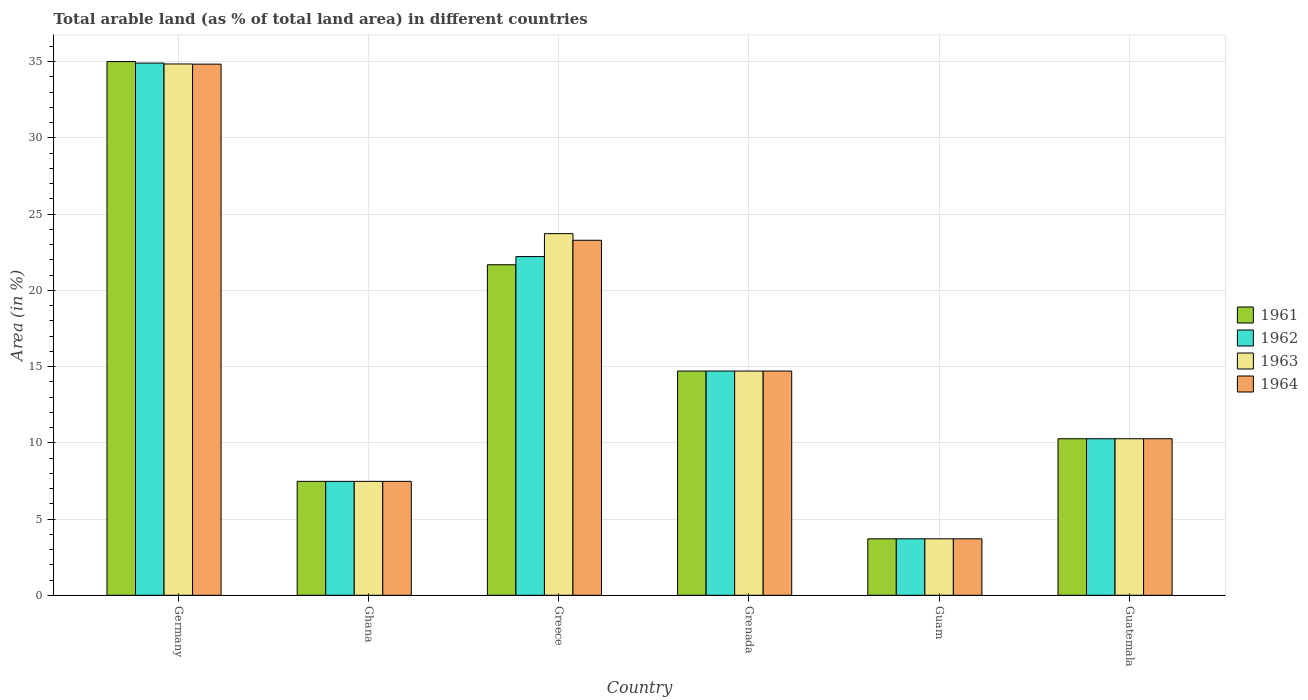How many groups of bars are there?
Make the answer very short. 6. Are the number of bars per tick equal to the number of legend labels?
Make the answer very short. Yes. Are the number of bars on each tick of the X-axis equal?
Give a very brief answer. Yes. How many bars are there on the 4th tick from the right?
Provide a short and direct response. 4. What is the label of the 1st group of bars from the left?
Ensure brevity in your answer.  Germany. What is the percentage of arable land in 1964 in Guam?
Offer a terse response. 3.7. Across all countries, what is the maximum percentage of arable land in 1964?
Your answer should be compact. 34.83. Across all countries, what is the minimum percentage of arable land in 1963?
Your response must be concise. 3.7. In which country was the percentage of arable land in 1963 maximum?
Offer a very short reply. Germany. In which country was the percentage of arable land in 1964 minimum?
Ensure brevity in your answer.  Guam. What is the total percentage of arable land in 1963 in the graph?
Offer a very short reply. 94.71. What is the difference between the percentage of arable land in 1961 in Greece and that in Grenada?
Offer a very short reply. 6.97. What is the difference between the percentage of arable land in 1961 in Germany and the percentage of arable land in 1962 in Guatemala?
Provide a short and direct response. 24.74. What is the average percentage of arable land in 1962 per country?
Ensure brevity in your answer.  15.54. What is the difference between the percentage of arable land of/in 1963 and percentage of arable land of/in 1961 in Germany?
Provide a succinct answer. -0.16. In how many countries, is the percentage of arable land in 1964 greater than 6 %?
Offer a terse response. 5. What is the ratio of the percentage of arable land in 1962 in Germany to that in Grenada?
Ensure brevity in your answer.  2.37. Is the percentage of arable land in 1961 in Greece less than that in Guam?
Ensure brevity in your answer.  No. What is the difference between the highest and the second highest percentage of arable land in 1963?
Make the answer very short. 20.14. What is the difference between the highest and the lowest percentage of arable land in 1962?
Make the answer very short. 31.2. In how many countries, is the percentage of arable land in 1963 greater than the average percentage of arable land in 1963 taken over all countries?
Provide a succinct answer. 2. Is it the case that in every country, the sum of the percentage of arable land in 1963 and percentage of arable land in 1962 is greater than the sum of percentage of arable land in 1961 and percentage of arable land in 1964?
Your response must be concise. No. What does the 3rd bar from the left in Ghana represents?
Make the answer very short. 1963. What does the 4th bar from the right in Ghana represents?
Your answer should be very brief. 1961. Is it the case that in every country, the sum of the percentage of arable land in 1963 and percentage of arable land in 1964 is greater than the percentage of arable land in 1961?
Ensure brevity in your answer.  Yes. What is the difference between two consecutive major ticks on the Y-axis?
Your answer should be very brief. 5. Does the graph contain any zero values?
Your answer should be compact. No. How many legend labels are there?
Provide a succinct answer. 4. What is the title of the graph?
Provide a short and direct response. Total arable land (as % of total land area) in different countries. Does "1981" appear as one of the legend labels in the graph?
Your response must be concise. No. What is the label or title of the X-axis?
Give a very brief answer. Country. What is the label or title of the Y-axis?
Make the answer very short. Area (in %). What is the Area (in %) of 1961 in Germany?
Make the answer very short. 35. What is the Area (in %) of 1962 in Germany?
Offer a very short reply. 34.9. What is the Area (in %) in 1963 in Germany?
Your response must be concise. 34.84. What is the Area (in %) in 1964 in Germany?
Ensure brevity in your answer.  34.83. What is the Area (in %) in 1961 in Ghana?
Your response must be concise. 7.47. What is the Area (in %) of 1962 in Ghana?
Offer a very short reply. 7.47. What is the Area (in %) in 1963 in Ghana?
Make the answer very short. 7.47. What is the Area (in %) in 1964 in Ghana?
Provide a short and direct response. 7.47. What is the Area (in %) of 1961 in Greece?
Provide a succinct answer. 21.68. What is the Area (in %) of 1962 in Greece?
Keep it short and to the point. 22.21. What is the Area (in %) of 1963 in Greece?
Keep it short and to the point. 23.72. What is the Area (in %) in 1964 in Greece?
Your answer should be compact. 23.28. What is the Area (in %) of 1961 in Grenada?
Your response must be concise. 14.71. What is the Area (in %) of 1962 in Grenada?
Offer a very short reply. 14.71. What is the Area (in %) in 1963 in Grenada?
Provide a succinct answer. 14.71. What is the Area (in %) in 1964 in Grenada?
Your answer should be very brief. 14.71. What is the Area (in %) of 1961 in Guam?
Keep it short and to the point. 3.7. What is the Area (in %) in 1962 in Guam?
Your answer should be compact. 3.7. What is the Area (in %) of 1963 in Guam?
Your response must be concise. 3.7. What is the Area (in %) of 1964 in Guam?
Make the answer very short. 3.7. What is the Area (in %) in 1961 in Guatemala?
Give a very brief answer. 10.27. What is the Area (in %) in 1962 in Guatemala?
Your response must be concise. 10.27. What is the Area (in %) of 1963 in Guatemala?
Your response must be concise. 10.27. What is the Area (in %) in 1964 in Guatemala?
Provide a short and direct response. 10.27. Across all countries, what is the maximum Area (in %) of 1961?
Ensure brevity in your answer.  35. Across all countries, what is the maximum Area (in %) in 1962?
Keep it short and to the point. 34.9. Across all countries, what is the maximum Area (in %) in 1963?
Provide a succinct answer. 34.84. Across all countries, what is the maximum Area (in %) of 1964?
Your answer should be very brief. 34.83. Across all countries, what is the minimum Area (in %) in 1961?
Offer a terse response. 3.7. Across all countries, what is the minimum Area (in %) of 1962?
Your response must be concise. 3.7. Across all countries, what is the minimum Area (in %) in 1963?
Make the answer very short. 3.7. Across all countries, what is the minimum Area (in %) in 1964?
Keep it short and to the point. 3.7. What is the total Area (in %) in 1961 in the graph?
Ensure brevity in your answer.  92.82. What is the total Area (in %) of 1962 in the graph?
Offer a terse response. 93.26. What is the total Area (in %) in 1963 in the graph?
Your answer should be compact. 94.71. What is the total Area (in %) of 1964 in the graph?
Provide a succinct answer. 94.26. What is the difference between the Area (in %) in 1961 in Germany and that in Ghana?
Ensure brevity in your answer.  27.53. What is the difference between the Area (in %) in 1962 in Germany and that in Ghana?
Ensure brevity in your answer.  27.43. What is the difference between the Area (in %) of 1963 in Germany and that in Ghana?
Provide a short and direct response. 27.37. What is the difference between the Area (in %) in 1964 in Germany and that in Ghana?
Offer a very short reply. 27.36. What is the difference between the Area (in %) in 1961 in Germany and that in Greece?
Ensure brevity in your answer.  13.33. What is the difference between the Area (in %) in 1962 in Germany and that in Greece?
Make the answer very short. 12.69. What is the difference between the Area (in %) in 1963 in Germany and that in Greece?
Your answer should be very brief. 11.13. What is the difference between the Area (in %) of 1964 in Germany and that in Greece?
Your answer should be compact. 11.55. What is the difference between the Area (in %) of 1961 in Germany and that in Grenada?
Offer a very short reply. 20.3. What is the difference between the Area (in %) in 1962 in Germany and that in Grenada?
Your answer should be compact. 20.2. What is the difference between the Area (in %) in 1963 in Germany and that in Grenada?
Your response must be concise. 20.14. What is the difference between the Area (in %) in 1964 in Germany and that in Grenada?
Your answer should be compact. 20.13. What is the difference between the Area (in %) of 1961 in Germany and that in Guam?
Your answer should be compact. 31.3. What is the difference between the Area (in %) in 1962 in Germany and that in Guam?
Your answer should be compact. 31.2. What is the difference between the Area (in %) of 1963 in Germany and that in Guam?
Ensure brevity in your answer.  31.14. What is the difference between the Area (in %) in 1964 in Germany and that in Guam?
Ensure brevity in your answer.  31.13. What is the difference between the Area (in %) in 1961 in Germany and that in Guatemala?
Ensure brevity in your answer.  24.74. What is the difference between the Area (in %) of 1962 in Germany and that in Guatemala?
Provide a short and direct response. 24.64. What is the difference between the Area (in %) in 1963 in Germany and that in Guatemala?
Provide a short and direct response. 24.58. What is the difference between the Area (in %) in 1964 in Germany and that in Guatemala?
Ensure brevity in your answer.  24.57. What is the difference between the Area (in %) in 1961 in Ghana and that in Greece?
Your answer should be very brief. -14.2. What is the difference between the Area (in %) of 1962 in Ghana and that in Greece?
Provide a succinct answer. -14.74. What is the difference between the Area (in %) in 1963 in Ghana and that in Greece?
Your response must be concise. -16.24. What is the difference between the Area (in %) in 1964 in Ghana and that in Greece?
Your answer should be very brief. -15.81. What is the difference between the Area (in %) of 1961 in Ghana and that in Grenada?
Provide a short and direct response. -7.23. What is the difference between the Area (in %) in 1962 in Ghana and that in Grenada?
Your answer should be very brief. -7.23. What is the difference between the Area (in %) of 1963 in Ghana and that in Grenada?
Keep it short and to the point. -7.23. What is the difference between the Area (in %) of 1964 in Ghana and that in Grenada?
Make the answer very short. -7.23. What is the difference between the Area (in %) of 1961 in Ghana and that in Guam?
Keep it short and to the point. 3.77. What is the difference between the Area (in %) of 1962 in Ghana and that in Guam?
Offer a terse response. 3.77. What is the difference between the Area (in %) of 1963 in Ghana and that in Guam?
Provide a succinct answer. 3.77. What is the difference between the Area (in %) in 1964 in Ghana and that in Guam?
Ensure brevity in your answer.  3.77. What is the difference between the Area (in %) in 1961 in Ghana and that in Guatemala?
Your response must be concise. -2.79. What is the difference between the Area (in %) in 1962 in Ghana and that in Guatemala?
Provide a succinct answer. -2.79. What is the difference between the Area (in %) in 1963 in Ghana and that in Guatemala?
Make the answer very short. -2.79. What is the difference between the Area (in %) in 1964 in Ghana and that in Guatemala?
Make the answer very short. -2.79. What is the difference between the Area (in %) of 1961 in Greece and that in Grenada?
Offer a very short reply. 6.97. What is the difference between the Area (in %) of 1962 in Greece and that in Grenada?
Your answer should be compact. 7.51. What is the difference between the Area (in %) in 1963 in Greece and that in Grenada?
Provide a succinct answer. 9.01. What is the difference between the Area (in %) of 1964 in Greece and that in Grenada?
Make the answer very short. 8.58. What is the difference between the Area (in %) of 1961 in Greece and that in Guam?
Keep it short and to the point. 17.97. What is the difference between the Area (in %) of 1962 in Greece and that in Guam?
Keep it short and to the point. 18.51. What is the difference between the Area (in %) in 1963 in Greece and that in Guam?
Your response must be concise. 20.01. What is the difference between the Area (in %) of 1964 in Greece and that in Guam?
Your answer should be compact. 19.58. What is the difference between the Area (in %) in 1961 in Greece and that in Guatemala?
Give a very brief answer. 11.41. What is the difference between the Area (in %) of 1962 in Greece and that in Guatemala?
Provide a short and direct response. 11.95. What is the difference between the Area (in %) in 1963 in Greece and that in Guatemala?
Your response must be concise. 13.45. What is the difference between the Area (in %) in 1964 in Greece and that in Guatemala?
Offer a terse response. 13.02. What is the difference between the Area (in %) of 1961 in Grenada and that in Guam?
Provide a succinct answer. 11. What is the difference between the Area (in %) of 1962 in Grenada and that in Guam?
Your response must be concise. 11. What is the difference between the Area (in %) in 1963 in Grenada and that in Guam?
Ensure brevity in your answer.  11. What is the difference between the Area (in %) in 1964 in Grenada and that in Guam?
Keep it short and to the point. 11. What is the difference between the Area (in %) in 1961 in Grenada and that in Guatemala?
Offer a very short reply. 4.44. What is the difference between the Area (in %) in 1962 in Grenada and that in Guatemala?
Provide a succinct answer. 4.44. What is the difference between the Area (in %) in 1963 in Grenada and that in Guatemala?
Provide a succinct answer. 4.44. What is the difference between the Area (in %) in 1964 in Grenada and that in Guatemala?
Make the answer very short. 4.44. What is the difference between the Area (in %) of 1961 in Guam and that in Guatemala?
Offer a terse response. -6.56. What is the difference between the Area (in %) in 1962 in Guam and that in Guatemala?
Give a very brief answer. -6.56. What is the difference between the Area (in %) of 1963 in Guam and that in Guatemala?
Ensure brevity in your answer.  -6.56. What is the difference between the Area (in %) of 1964 in Guam and that in Guatemala?
Your answer should be very brief. -6.56. What is the difference between the Area (in %) in 1961 in Germany and the Area (in %) in 1962 in Ghana?
Your response must be concise. 27.53. What is the difference between the Area (in %) of 1961 in Germany and the Area (in %) of 1963 in Ghana?
Offer a terse response. 27.53. What is the difference between the Area (in %) of 1961 in Germany and the Area (in %) of 1964 in Ghana?
Your answer should be very brief. 27.53. What is the difference between the Area (in %) of 1962 in Germany and the Area (in %) of 1963 in Ghana?
Offer a terse response. 27.43. What is the difference between the Area (in %) in 1962 in Germany and the Area (in %) in 1964 in Ghana?
Provide a short and direct response. 27.43. What is the difference between the Area (in %) in 1963 in Germany and the Area (in %) in 1964 in Ghana?
Give a very brief answer. 27.37. What is the difference between the Area (in %) of 1961 in Germany and the Area (in %) of 1962 in Greece?
Make the answer very short. 12.79. What is the difference between the Area (in %) of 1961 in Germany and the Area (in %) of 1963 in Greece?
Provide a succinct answer. 11.29. What is the difference between the Area (in %) in 1961 in Germany and the Area (in %) in 1964 in Greece?
Give a very brief answer. 11.72. What is the difference between the Area (in %) in 1962 in Germany and the Area (in %) in 1963 in Greece?
Your answer should be compact. 11.19. What is the difference between the Area (in %) of 1962 in Germany and the Area (in %) of 1964 in Greece?
Ensure brevity in your answer.  11.62. What is the difference between the Area (in %) in 1963 in Germany and the Area (in %) in 1964 in Greece?
Make the answer very short. 11.56. What is the difference between the Area (in %) of 1961 in Germany and the Area (in %) of 1962 in Grenada?
Give a very brief answer. 20.3. What is the difference between the Area (in %) of 1961 in Germany and the Area (in %) of 1963 in Grenada?
Ensure brevity in your answer.  20.3. What is the difference between the Area (in %) of 1961 in Germany and the Area (in %) of 1964 in Grenada?
Your answer should be very brief. 20.3. What is the difference between the Area (in %) in 1962 in Germany and the Area (in %) in 1963 in Grenada?
Offer a very short reply. 20.2. What is the difference between the Area (in %) of 1962 in Germany and the Area (in %) of 1964 in Grenada?
Offer a terse response. 20.2. What is the difference between the Area (in %) of 1963 in Germany and the Area (in %) of 1964 in Grenada?
Your answer should be compact. 20.14. What is the difference between the Area (in %) of 1961 in Germany and the Area (in %) of 1962 in Guam?
Provide a succinct answer. 31.3. What is the difference between the Area (in %) of 1961 in Germany and the Area (in %) of 1963 in Guam?
Your response must be concise. 31.3. What is the difference between the Area (in %) in 1961 in Germany and the Area (in %) in 1964 in Guam?
Provide a succinct answer. 31.3. What is the difference between the Area (in %) of 1962 in Germany and the Area (in %) of 1963 in Guam?
Make the answer very short. 31.2. What is the difference between the Area (in %) in 1962 in Germany and the Area (in %) in 1964 in Guam?
Your answer should be very brief. 31.2. What is the difference between the Area (in %) of 1963 in Germany and the Area (in %) of 1964 in Guam?
Your answer should be compact. 31.14. What is the difference between the Area (in %) of 1961 in Germany and the Area (in %) of 1962 in Guatemala?
Your response must be concise. 24.74. What is the difference between the Area (in %) in 1961 in Germany and the Area (in %) in 1963 in Guatemala?
Provide a short and direct response. 24.74. What is the difference between the Area (in %) of 1961 in Germany and the Area (in %) of 1964 in Guatemala?
Provide a short and direct response. 24.74. What is the difference between the Area (in %) in 1962 in Germany and the Area (in %) in 1963 in Guatemala?
Make the answer very short. 24.64. What is the difference between the Area (in %) in 1962 in Germany and the Area (in %) in 1964 in Guatemala?
Offer a very short reply. 24.64. What is the difference between the Area (in %) of 1963 in Germany and the Area (in %) of 1964 in Guatemala?
Your response must be concise. 24.58. What is the difference between the Area (in %) of 1961 in Ghana and the Area (in %) of 1962 in Greece?
Offer a very short reply. -14.74. What is the difference between the Area (in %) in 1961 in Ghana and the Area (in %) in 1963 in Greece?
Your answer should be very brief. -16.24. What is the difference between the Area (in %) of 1961 in Ghana and the Area (in %) of 1964 in Greece?
Your response must be concise. -15.81. What is the difference between the Area (in %) in 1962 in Ghana and the Area (in %) in 1963 in Greece?
Offer a terse response. -16.24. What is the difference between the Area (in %) of 1962 in Ghana and the Area (in %) of 1964 in Greece?
Keep it short and to the point. -15.81. What is the difference between the Area (in %) in 1963 in Ghana and the Area (in %) in 1964 in Greece?
Ensure brevity in your answer.  -15.81. What is the difference between the Area (in %) of 1961 in Ghana and the Area (in %) of 1962 in Grenada?
Provide a short and direct response. -7.23. What is the difference between the Area (in %) of 1961 in Ghana and the Area (in %) of 1963 in Grenada?
Offer a very short reply. -7.23. What is the difference between the Area (in %) of 1961 in Ghana and the Area (in %) of 1964 in Grenada?
Offer a very short reply. -7.23. What is the difference between the Area (in %) of 1962 in Ghana and the Area (in %) of 1963 in Grenada?
Your response must be concise. -7.23. What is the difference between the Area (in %) in 1962 in Ghana and the Area (in %) in 1964 in Grenada?
Give a very brief answer. -7.23. What is the difference between the Area (in %) of 1963 in Ghana and the Area (in %) of 1964 in Grenada?
Provide a succinct answer. -7.23. What is the difference between the Area (in %) of 1961 in Ghana and the Area (in %) of 1962 in Guam?
Your answer should be compact. 3.77. What is the difference between the Area (in %) in 1961 in Ghana and the Area (in %) in 1963 in Guam?
Keep it short and to the point. 3.77. What is the difference between the Area (in %) of 1961 in Ghana and the Area (in %) of 1964 in Guam?
Keep it short and to the point. 3.77. What is the difference between the Area (in %) of 1962 in Ghana and the Area (in %) of 1963 in Guam?
Give a very brief answer. 3.77. What is the difference between the Area (in %) of 1962 in Ghana and the Area (in %) of 1964 in Guam?
Give a very brief answer. 3.77. What is the difference between the Area (in %) of 1963 in Ghana and the Area (in %) of 1964 in Guam?
Ensure brevity in your answer.  3.77. What is the difference between the Area (in %) of 1961 in Ghana and the Area (in %) of 1962 in Guatemala?
Give a very brief answer. -2.79. What is the difference between the Area (in %) of 1961 in Ghana and the Area (in %) of 1963 in Guatemala?
Provide a succinct answer. -2.79. What is the difference between the Area (in %) in 1961 in Ghana and the Area (in %) in 1964 in Guatemala?
Give a very brief answer. -2.79. What is the difference between the Area (in %) in 1962 in Ghana and the Area (in %) in 1963 in Guatemala?
Provide a short and direct response. -2.79. What is the difference between the Area (in %) in 1962 in Ghana and the Area (in %) in 1964 in Guatemala?
Your answer should be very brief. -2.79. What is the difference between the Area (in %) in 1963 in Ghana and the Area (in %) in 1964 in Guatemala?
Keep it short and to the point. -2.79. What is the difference between the Area (in %) in 1961 in Greece and the Area (in %) in 1962 in Grenada?
Your response must be concise. 6.97. What is the difference between the Area (in %) of 1961 in Greece and the Area (in %) of 1963 in Grenada?
Make the answer very short. 6.97. What is the difference between the Area (in %) in 1961 in Greece and the Area (in %) in 1964 in Grenada?
Your answer should be compact. 6.97. What is the difference between the Area (in %) of 1962 in Greece and the Area (in %) of 1963 in Grenada?
Offer a terse response. 7.51. What is the difference between the Area (in %) of 1962 in Greece and the Area (in %) of 1964 in Grenada?
Provide a short and direct response. 7.51. What is the difference between the Area (in %) of 1963 in Greece and the Area (in %) of 1964 in Grenada?
Give a very brief answer. 9.01. What is the difference between the Area (in %) of 1961 in Greece and the Area (in %) of 1962 in Guam?
Offer a very short reply. 17.97. What is the difference between the Area (in %) of 1961 in Greece and the Area (in %) of 1963 in Guam?
Your answer should be very brief. 17.97. What is the difference between the Area (in %) of 1961 in Greece and the Area (in %) of 1964 in Guam?
Your answer should be compact. 17.97. What is the difference between the Area (in %) in 1962 in Greece and the Area (in %) in 1963 in Guam?
Make the answer very short. 18.51. What is the difference between the Area (in %) in 1962 in Greece and the Area (in %) in 1964 in Guam?
Your answer should be very brief. 18.51. What is the difference between the Area (in %) in 1963 in Greece and the Area (in %) in 1964 in Guam?
Offer a terse response. 20.01. What is the difference between the Area (in %) in 1961 in Greece and the Area (in %) in 1962 in Guatemala?
Offer a terse response. 11.41. What is the difference between the Area (in %) of 1961 in Greece and the Area (in %) of 1963 in Guatemala?
Offer a terse response. 11.41. What is the difference between the Area (in %) of 1961 in Greece and the Area (in %) of 1964 in Guatemala?
Your response must be concise. 11.41. What is the difference between the Area (in %) in 1962 in Greece and the Area (in %) in 1963 in Guatemala?
Make the answer very short. 11.95. What is the difference between the Area (in %) in 1962 in Greece and the Area (in %) in 1964 in Guatemala?
Provide a short and direct response. 11.95. What is the difference between the Area (in %) of 1963 in Greece and the Area (in %) of 1964 in Guatemala?
Provide a short and direct response. 13.45. What is the difference between the Area (in %) of 1961 in Grenada and the Area (in %) of 1962 in Guam?
Make the answer very short. 11. What is the difference between the Area (in %) in 1961 in Grenada and the Area (in %) in 1963 in Guam?
Your answer should be compact. 11. What is the difference between the Area (in %) of 1961 in Grenada and the Area (in %) of 1964 in Guam?
Your answer should be compact. 11. What is the difference between the Area (in %) in 1962 in Grenada and the Area (in %) in 1963 in Guam?
Your answer should be compact. 11. What is the difference between the Area (in %) of 1962 in Grenada and the Area (in %) of 1964 in Guam?
Your answer should be very brief. 11. What is the difference between the Area (in %) in 1963 in Grenada and the Area (in %) in 1964 in Guam?
Ensure brevity in your answer.  11. What is the difference between the Area (in %) of 1961 in Grenada and the Area (in %) of 1962 in Guatemala?
Your answer should be compact. 4.44. What is the difference between the Area (in %) in 1961 in Grenada and the Area (in %) in 1963 in Guatemala?
Offer a terse response. 4.44. What is the difference between the Area (in %) in 1961 in Grenada and the Area (in %) in 1964 in Guatemala?
Your answer should be compact. 4.44. What is the difference between the Area (in %) of 1962 in Grenada and the Area (in %) of 1963 in Guatemala?
Your response must be concise. 4.44. What is the difference between the Area (in %) of 1962 in Grenada and the Area (in %) of 1964 in Guatemala?
Your response must be concise. 4.44. What is the difference between the Area (in %) of 1963 in Grenada and the Area (in %) of 1964 in Guatemala?
Provide a short and direct response. 4.44. What is the difference between the Area (in %) of 1961 in Guam and the Area (in %) of 1962 in Guatemala?
Your response must be concise. -6.56. What is the difference between the Area (in %) of 1961 in Guam and the Area (in %) of 1963 in Guatemala?
Your answer should be compact. -6.56. What is the difference between the Area (in %) in 1961 in Guam and the Area (in %) in 1964 in Guatemala?
Keep it short and to the point. -6.56. What is the difference between the Area (in %) of 1962 in Guam and the Area (in %) of 1963 in Guatemala?
Offer a terse response. -6.56. What is the difference between the Area (in %) in 1962 in Guam and the Area (in %) in 1964 in Guatemala?
Offer a terse response. -6.56. What is the difference between the Area (in %) of 1963 in Guam and the Area (in %) of 1964 in Guatemala?
Provide a short and direct response. -6.56. What is the average Area (in %) of 1961 per country?
Offer a terse response. 15.47. What is the average Area (in %) in 1962 per country?
Your answer should be compact. 15.54. What is the average Area (in %) of 1963 per country?
Offer a terse response. 15.78. What is the average Area (in %) in 1964 per country?
Your response must be concise. 15.71. What is the difference between the Area (in %) in 1961 and Area (in %) in 1962 in Germany?
Provide a short and direct response. 0.1. What is the difference between the Area (in %) of 1961 and Area (in %) of 1963 in Germany?
Provide a short and direct response. 0.16. What is the difference between the Area (in %) in 1961 and Area (in %) in 1964 in Germany?
Ensure brevity in your answer.  0.17. What is the difference between the Area (in %) of 1962 and Area (in %) of 1963 in Germany?
Keep it short and to the point. 0.06. What is the difference between the Area (in %) of 1962 and Area (in %) of 1964 in Germany?
Your response must be concise. 0.07. What is the difference between the Area (in %) in 1963 and Area (in %) in 1964 in Germany?
Keep it short and to the point. 0.01. What is the difference between the Area (in %) of 1961 and Area (in %) of 1962 in Ghana?
Offer a terse response. 0. What is the difference between the Area (in %) of 1962 and Area (in %) of 1963 in Ghana?
Your answer should be very brief. 0. What is the difference between the Area (in %) in 1961 and Area (in %) in 1962 in Greece?
Ensure brevity in your answer.  -0.54. What is the difference between the Area (in %) in 1961 and Area (in %) in 1963 in Greece?
Offer a very short reply. -2.04. What is the difference between the Area (in %) in 1961 and Area (in %) in 1964 in Greece?
Keep it short and to the point. -1.61. What is the difference between the Area (in %) in 1962 and Area (in %) in 1963 in Greece?
Offer a terse response. -1.5. What is the difference between the Area (in %) in 1962 and Area (in %) in 1964 in Greece?
Your answer should be very brief. -1.07. What is the difference between the Area (in %) of 1963 and Area (in %) of 1964 in Greece?
Provide a succinct answer. 0.43. What is the difference between the Area (in %) in 1961 and Area (in %) in 1963 in Grenada?
Your response must be concise. 0. What is the difference between the Area (in %) of 1961 and Area (in %) of 1964 in Grenada?
Provide a short and direct response. 0. What is the difference between the Area (in %) of 1962 and Area (in %) of 1963 in Grenada?
Provide a succinct answer. 0. What is the difference between the Area (in %) in 1961 and Area (in %) in 1963 in Guam?
Your answer should be very brief. 0. What is the difference between the Area (in %) of 1961 and Area (in %) of 1964 in Guam?
Provide a short and direct response. 0. What is the difference between the Area (in %) of 1962 and Area (in %) of 1963 in Guam?
Offer a very short reply. 0. What is the difference between the Area (in %) in 1961 and Area (in %) in 1964 in Guatemala?
Provide a short and direct response. 0. What is the difference between the Area (in %) of 1962 and Area (in %) of 1964 in Guatemala?
Give a very brief answer. 0. What is the ratio of the Area (in %) of 1961 in Germany to that in Ghana?
Your answer should be very brief. 4.68. What is the ratio of the Area (in %) of 1962 in Germany to that in Ghana?
Your answer should be compact. 4.67. What is the ratio of the Area (in %) in 1963 in Germany to that in Ghana?
Keep it short and to the point. 4.66. What is the ratio of the Area (in %) in 1964 in Germany to that in Ghana?
Your answer should be very brief. 4.66. What is the ratio of the Area (in %) in 1961 in Germany to that in Greece?
Provide a succinct answer. 1.61. What is the ratio of the Area (in %) in 1962 in Germany to that in Greece?
Offer a terse response. 1.57. What is the ratio of the Area (in %) in 1963 in Germany to that in Greece?
Provide a short and direct response. 1.47. What is the ratio of the Area (in %) of 1964 in Germany to that in Greece?
Offer a terse response. 1.5. What is the ratio of the Area (in %) of 1961 in Germany to that in Grenada?
Make the answer very short. 2.38. What is the ratio of the Area (in %) of 1962 in Germany to that in Grenada?
Make the answer very short. 2.37. What is the ratio of the Area (in %) of 1963 in Germany to that in Grenada?
Give a very brief answer. 2.37. What is the ratio of the Area (in %) of 1964 in Germany to that in Grenada?
Offer a very short reply. 2.37. What is the ratio of the Area (in %) in 1961 in Germany to that in Guam?
Your answer should be compact. 9.45. What is the ratio of the Area (in %) in 1962 in Germany to that in Guam?
Give a very brief answer. 9.42. What is the ratio of the Area (in %) in 1963 in Germany to that in Guam?
Keep it short and to the point. 9.41. What is the ratio of the Area (in %) in 1964 in Germany to that in Guam?
Keep it short and to the point. 9.4. What is the ratio of the Area (in %) of 1961 in Germany to that in Guatemala?
Offer a terse response. 3.41. What is the ratio of the Area (in %) in 1962 in Germany to that in Guatemala?
Your response must be concise. 3.4. What is the ratio of the Area (in %) in 1963 in Germany to that in Guatemala?
Your answer should be compact. 3.39. What is the ratio of the Area (in %) of 1964 in Germany to that in Guatemala?
Provide a short and direct response. 3.39. What is the ratio of the Area (in %) in 1961 in Ghana to that in Greece?
Offer a terse response. 0.34. What is the ratio of the Area (in %) in 1962 in Ghana to that in Greece?
Offer a very short reply. 0.34. What is the ratio of the Area (in %) of 1963 in Ghana to that in Greece?
Keep it short and to the point. 0.32. What is the ratio of the Area (in %) in 1964 in Ghana to that in Greece?
Give a very brief answer. 0.32. What is the ratio of the Area (in %) of 1961 in Ghana to that in Grenada?
Offer a terse response. 0.51. What is the ratio of the Area (in %) in 1962 in Ghana to that in Grenada?
Offer a terse response. 0.51. What is the ratio of the Area (in %) in 1963 in Ghana to that in Grenada?
Your answer should be very brief. 0.51. What is the ratio of the Area (in %) of 1964 in Ghana to that in Grenada?
Your answer should be compact. 0.51. What is the ratio of the Area (in %) of 1961 in Ghana to that in Guam?
Give a very brief answer. 2.02. What is the ratio of the Area (in %) of 1962 in Ghana to that in Guam?
Give a very brief answer. 2.02. What is the ratio of the Area (in %) in 1963 in Ghana to that in Guam?
Provide a short and direct response. 2.02. What is the ratio of the Area (in %) in 1964 in Ghana to that in Guam?
Make the answer very short. 2.02. What is the ratio of the Area (in %) in 1961 in Ghana to that in Guatemala?
Your response must be concise. 0.73. What is the ratio of the Area (in %) of 1962 in Ghana to that in Guatemala?
Give a very brief answer. 0.73. What is the ratio of the Area (in %) of 1963 in Ghana to that in Guatemala?
Your answer should be very brief. 0.73. What is the ratio of the Area (in %) in 1964 in Ghana to that in Guatemala?
Provide a succinct answer. 0.73. What is the ratio of the Area (in %) of 1961 in Greece to that in Grenada?
Ensure brevity in your answer.  1.47. What is the ratio of the Area (in %) of 1962 in Greece to that in Grenada?
Your response must be concise. 1.51. What is the ratio of the Area (in %) in 1963 in Greece to that in Grenada?
Keep it short and to the point. 1.61. What is the ratio of the Area (in %) in 1964 in Greece to that in Grenada?
Offer a very short reply. 1.58. What is the ratio of the Area (in %) of 1961 in Greece to that in Guam?
Your response must be concise. 5.85. What is the ratio of the Area (in %) in 1962 in Greece to that in Guam?
Provide a succinct answer. 6. What is the ratio of the Area (in %) of 1963 in Greece to that in Guam?
Ensure brevity in your answer.  6.4. What is the ratio of the Area (in %) in 1964 in Greece to that in Guam?
Give a very brief answer. 6.29. What is the ratio of the Area (in %) in 1961 in Greece to that in Guatemala?
Make the answer very short. 2.11. What is the ratio of the Area (in %) in 1962 in Greece to that in Guatemala?
Offer a terse response. 2.16. What is the ratio of the Area (in %) in 1963 in Greece to that in Guatemala?
Your answer should be compact. 2.31. What is the ratio of the Area (in %) in 1964 in Greece to that in Guatemala?
Give a very brief answer. 2.27. What is the ratio of the Area (in %) in 1961 in Grenada to that in Guam?
Offer a very short reply. 3.97. What is the ratio of the Area (in %) of 1962 in Grenada to that in Guam?
Your answer should be compact. 3.97. What is the ratio of the Area (in %) in 1963 in Grenada to that in Guam?
Offer a terse response. 3.97. What is the ratio of the Area (in %) of 1964 in Grenada to that in Guam?
Make the answer very short. 3.97. What is the ratio of the Area (in %) of 1961 in Grenada to that in Guatemala?
Your response must be concise. 1.43. What is the ratio of the Area (in %) of 1962 in Grenada to that in Guatemala?
Ensure brevity in your answer.  1.43. What is the ratio of the Area (in %) in 1963 in Grenada to that in Guatemala?
Your answer should be very brief. 1.43. What is the ratio of the Area (in %) of 1964 in Grenada to that in Guatemala?
Provide a short and direct response. 1.43. What is the ratio of the Area (in %) in 1961 in Guam to that in Guatemala?
Offer a very short reply. 0.36. What is the ratio of the Area (in %) of 1962 in Guam to that in Guatemala?
Keep it short and to the point. 0.36. What is the ratio of the Area (in %) of 1963 in Guam to that in Guatemala?
Offer a very short reply. 0.36. What is the ratio of the Area (in %) in 1964 in Guam to that in Guatemala?
Offer a terse response. 0.36. What is the difference between the highest and the second highest Area (in %) in 1961?
Offer a terse response. 13.33. What is the difference between the highest and the second highest Area (in %) of 1962?
Offer a terse response. 12.69. What is the difference between the highest and the second highest Area (in %) in 1963?
Your response must be concise. 11.13. What is the difference between the highest and the second highest Area (in %) of 1964?
Offer a terse response. 11.55. What is the difference between the highest and the lowest Area (in %) of 1961?
Offer a very short reply. 31.3. What is the difference between the highest and the lowest Area (in %) in 1962?
Ensure brevity in your answer.  31.2. What is the difference between the highest and the lowest Area (in %) of 1963?
Ensure brevity in your answer.  31.14. What is the difference between the highest and the lowest Area (in %) of 1964?
Give a very brief answer. 31.13. 